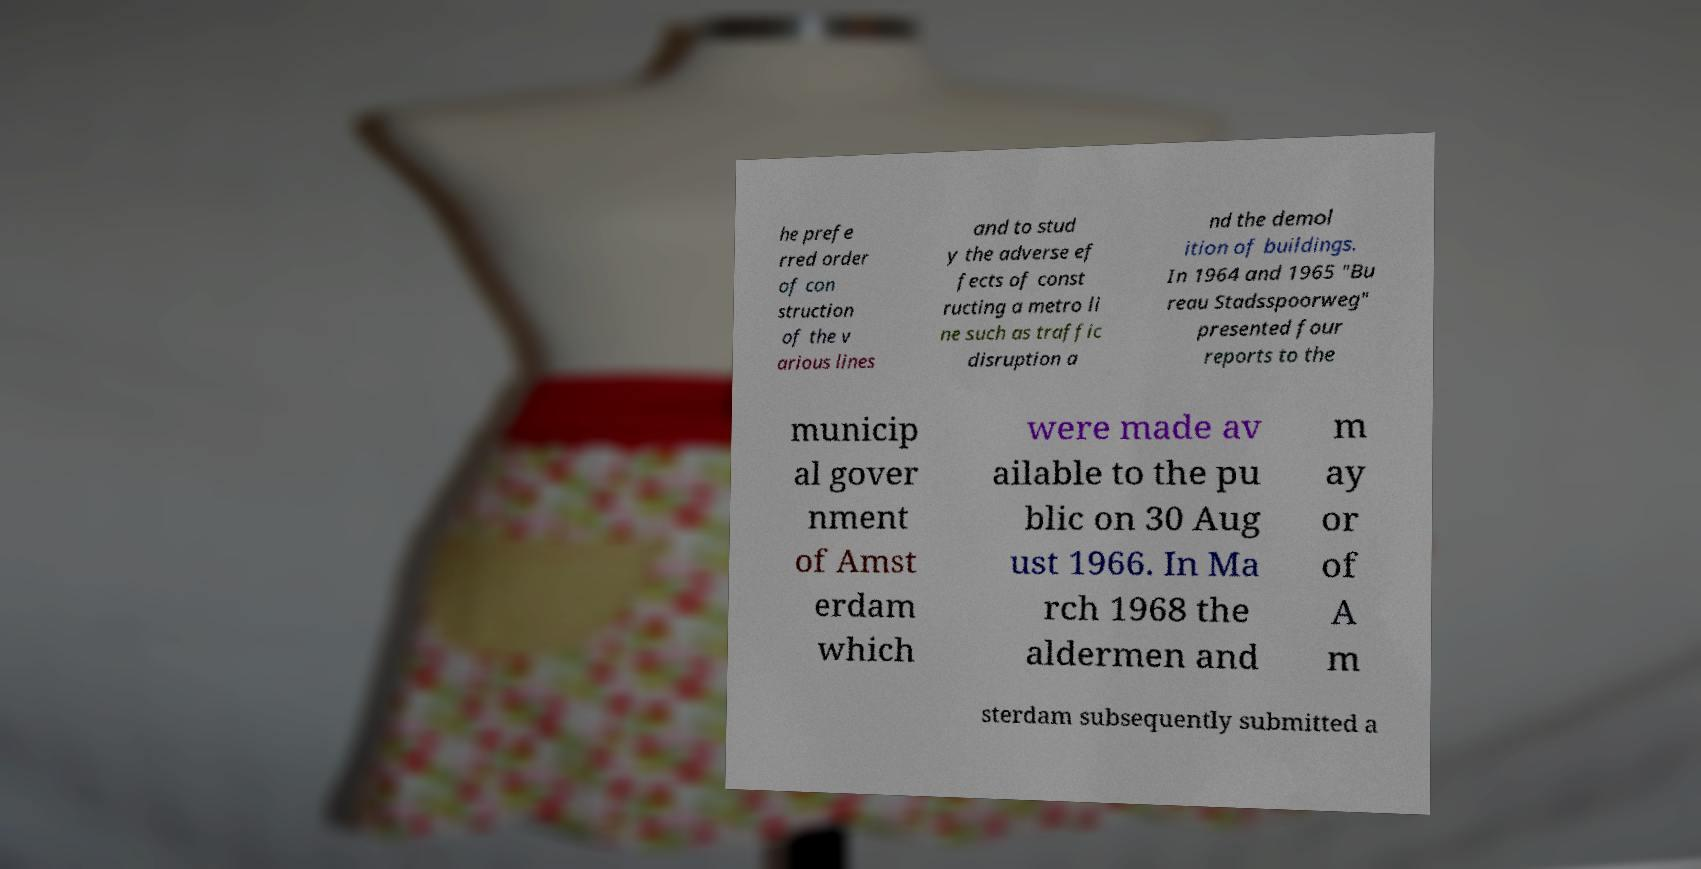Please read and relay the text visible in this image. What does it say? he prefe rred order of con struction of the v arious lines and to stud y the adverse ef fects of const ructing a metro li ne such as traffic disruption a nd the demol ition of buildings. In 1964 and 1965 "Bu reau Stadsspoorweg" presented four reports to the municip al gover nment of Amst erdam which were made av ailable to the pu blic on 30 Aug ust 1966. In Ma rch 1968 the aldermen and m ay or of A m sterdam subsequently submitted a 